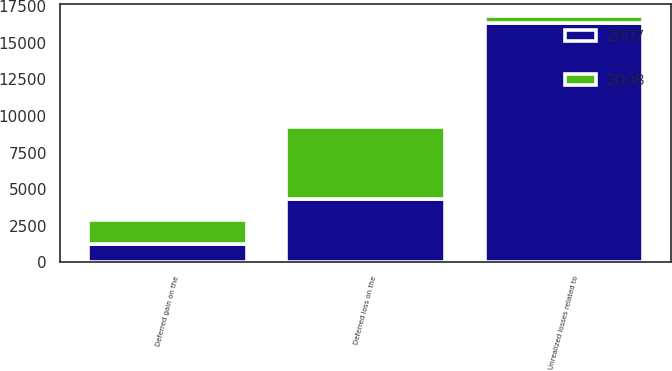<chart> <loc_0><loc_0><loc_500><loc_500><stacked_bar_chart><ecel><fcel>Deferred loss on the<fcel>Deferred gain on the<fcel>Unrealized losses related to<nl><fcel>2007<fcel>4332<fcel>1238<fcel>16349<nl><fcel>2008<fcel>4901<fcel>1636<fcel>486<nl></chart> 